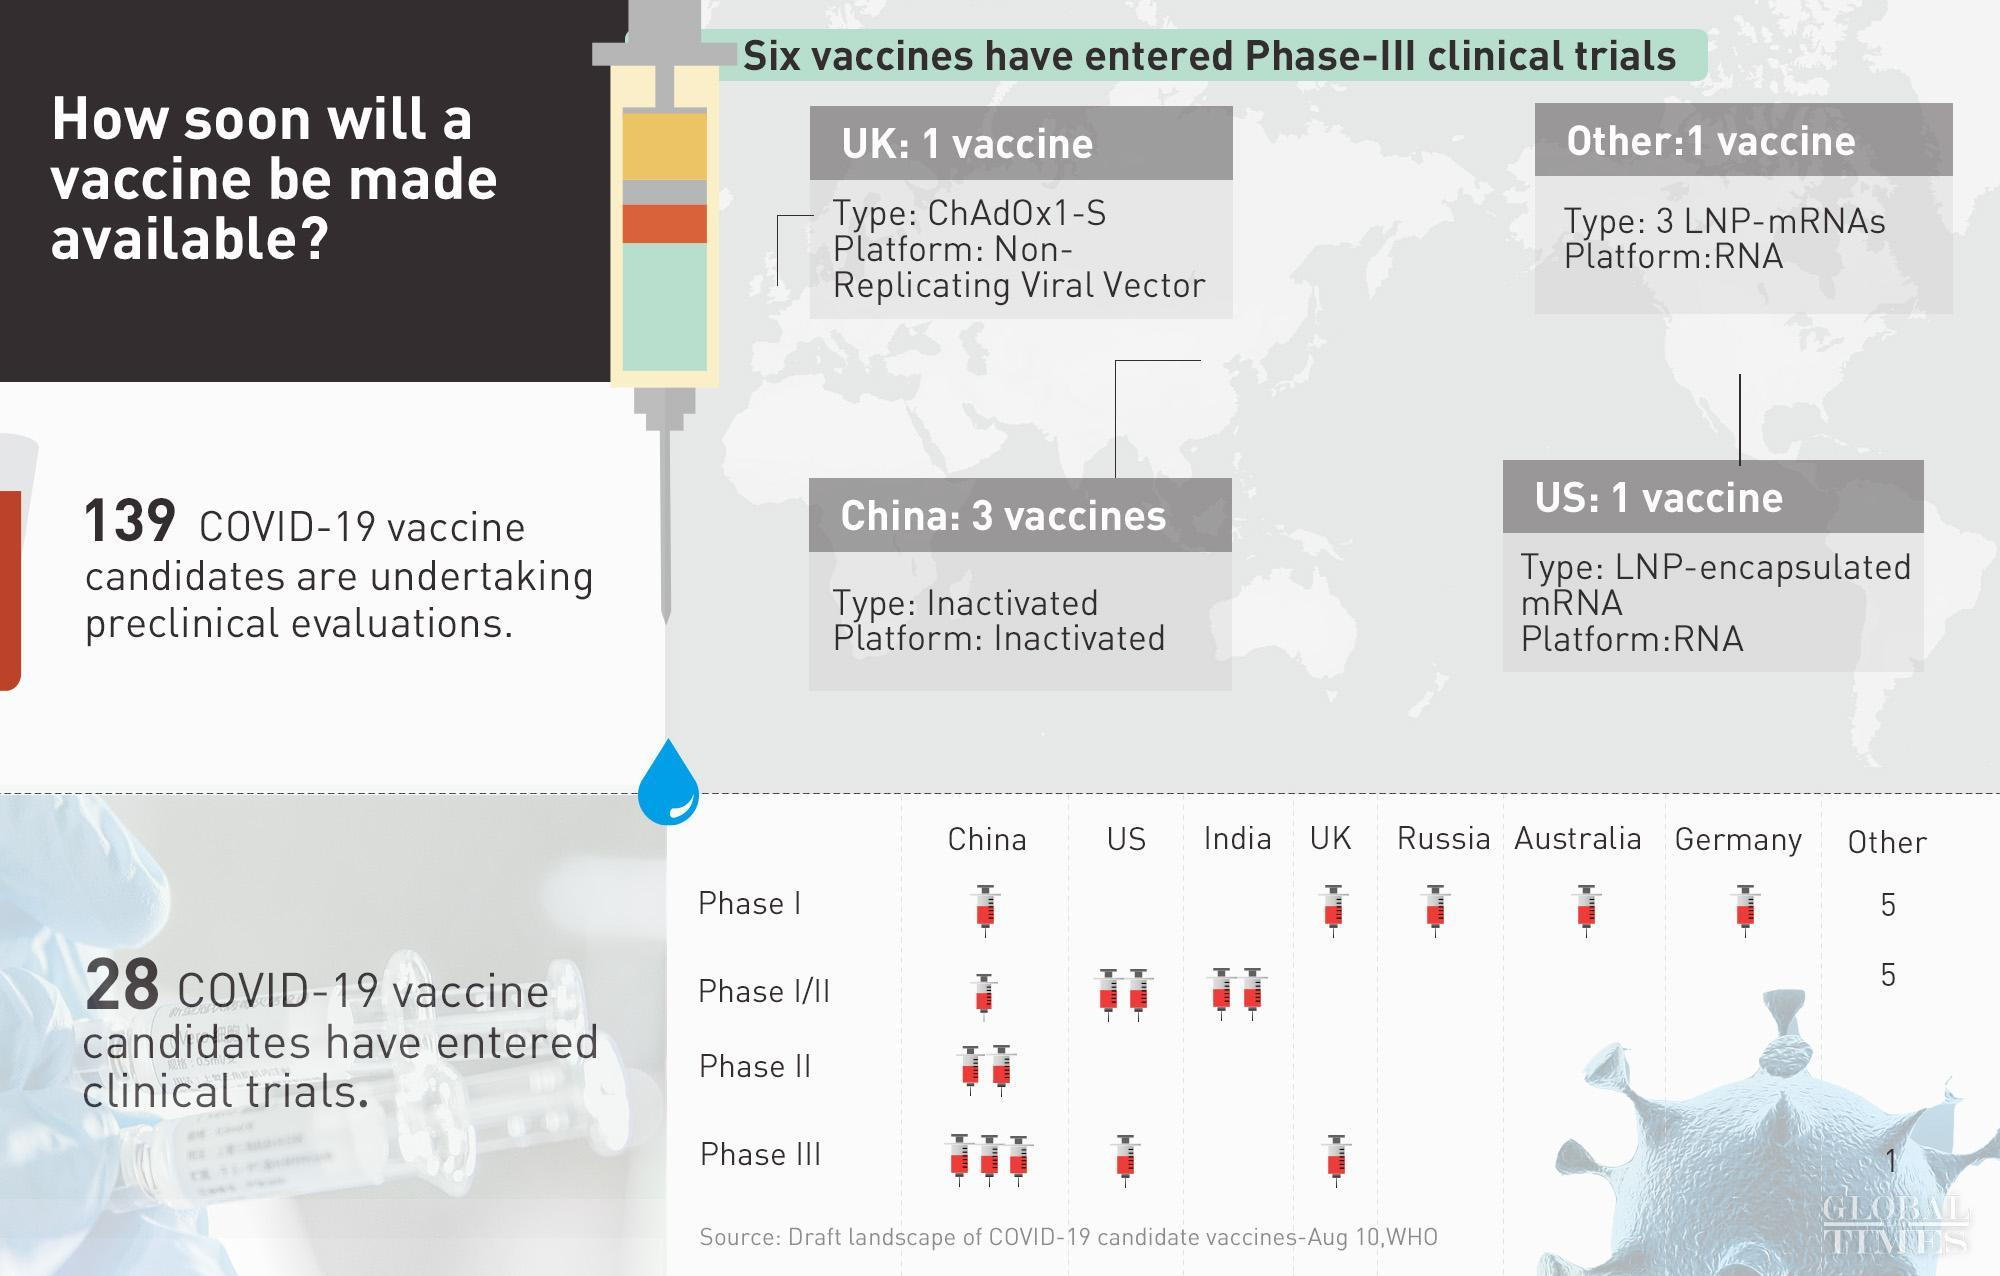How many vaccine candidates of UK have entered clinical trial?
Answer the question with a short phrase. 2 How many vaccines are there in third phase? 6 how many countries are given specifically in the right bottom table? 7 How many vaccine candidates of China have entered clinical trial? 7 How many vaccines are there in phase I/II? 10 How many vaccines are there in second phase? 2 How many vaccine candidates of Germany have entered clinical trial? 1 How many vaccine candidates of US have entered clinical trial? 3 How many vaccines are there in first phase? 10 How many vaccine candidates of Australia have entered clinical trial? 1 How many vaccine candidates of Russia have entered clinical trial? 1 How many vaccine candidates of India have entered clinical trial? 2 